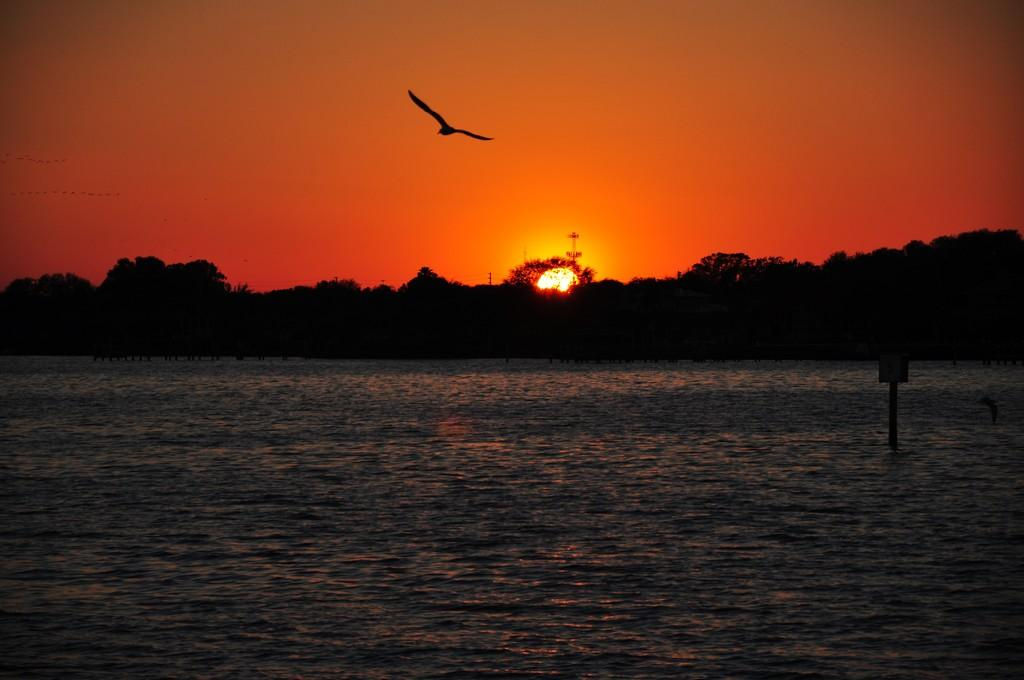What type of animal can be seen in the image? There is a bird in the image. What is the bird doing in the image? The bird is flying in the air. What natural element is visible in the image? There is water visible in the image. What type of vegetation can be seen in the image? There are trees in the image. What is visible in the background of the image? The sky is visible in the image. Where is the kitten playing with a curve in the image? There is no kitten or curve present in the image. What type of lumber is being used to build the bird's nest in the image? There is no bird's nest or lumber present in the image. 